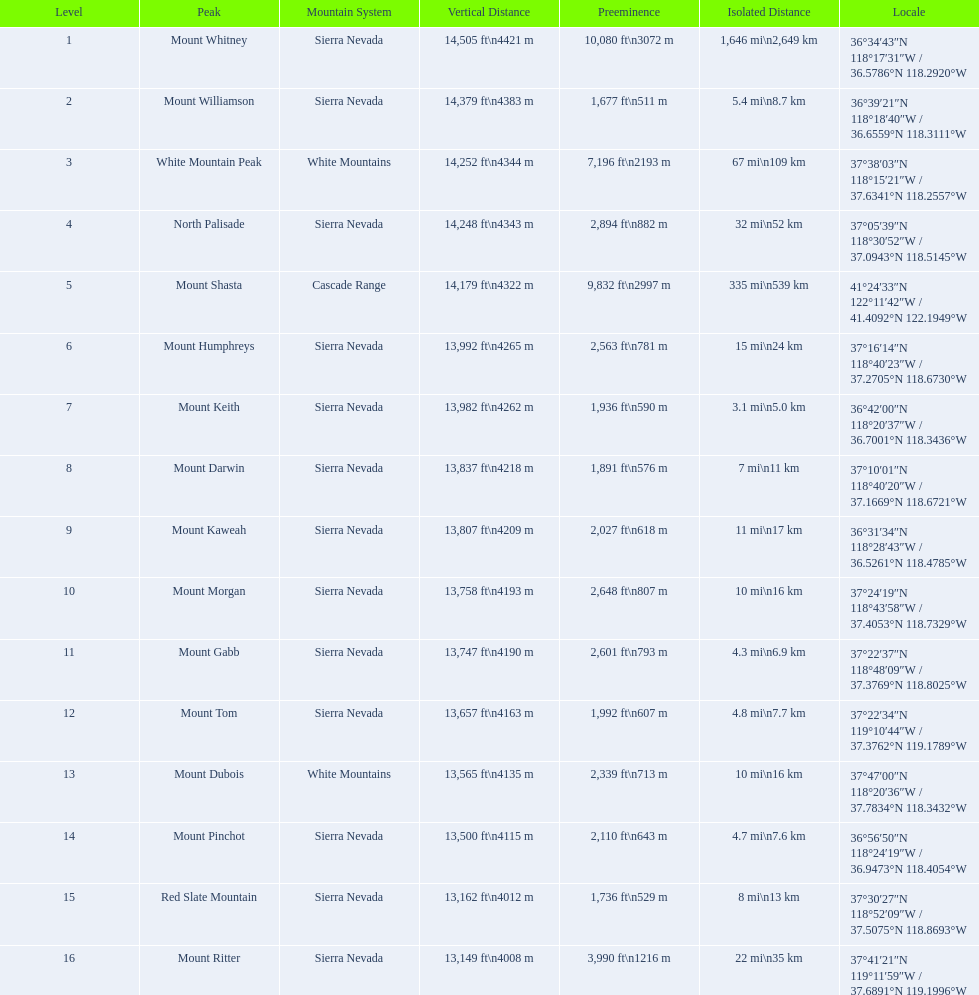What are the listed elevations? 14,505 ft\n4421 m, 14,379 ft\n4383 m, 14,252 ft\n4344 m, 14,248 ft\n4343 m, 14,179 ft\n4322 m, 13,992 ft\n4265 m, 13,982 ft\n4262 m, 13,837 ft\n4218 m, 13,807 ft\n4209 m, 13,758 ft\n4193 m, 13,747 ft\n4190 m, 13,657 ft\n4163 m, 13,565 ft\n4135 m, 13,500 ft\n4115 m, 13,162 ft\n4012 m, 13,149 ft\n4008 m. Which of those is 13,149 ft or below? 13,149 ft\n4008 m. To what mountain peak does that value correspond? Mount Ritter. 